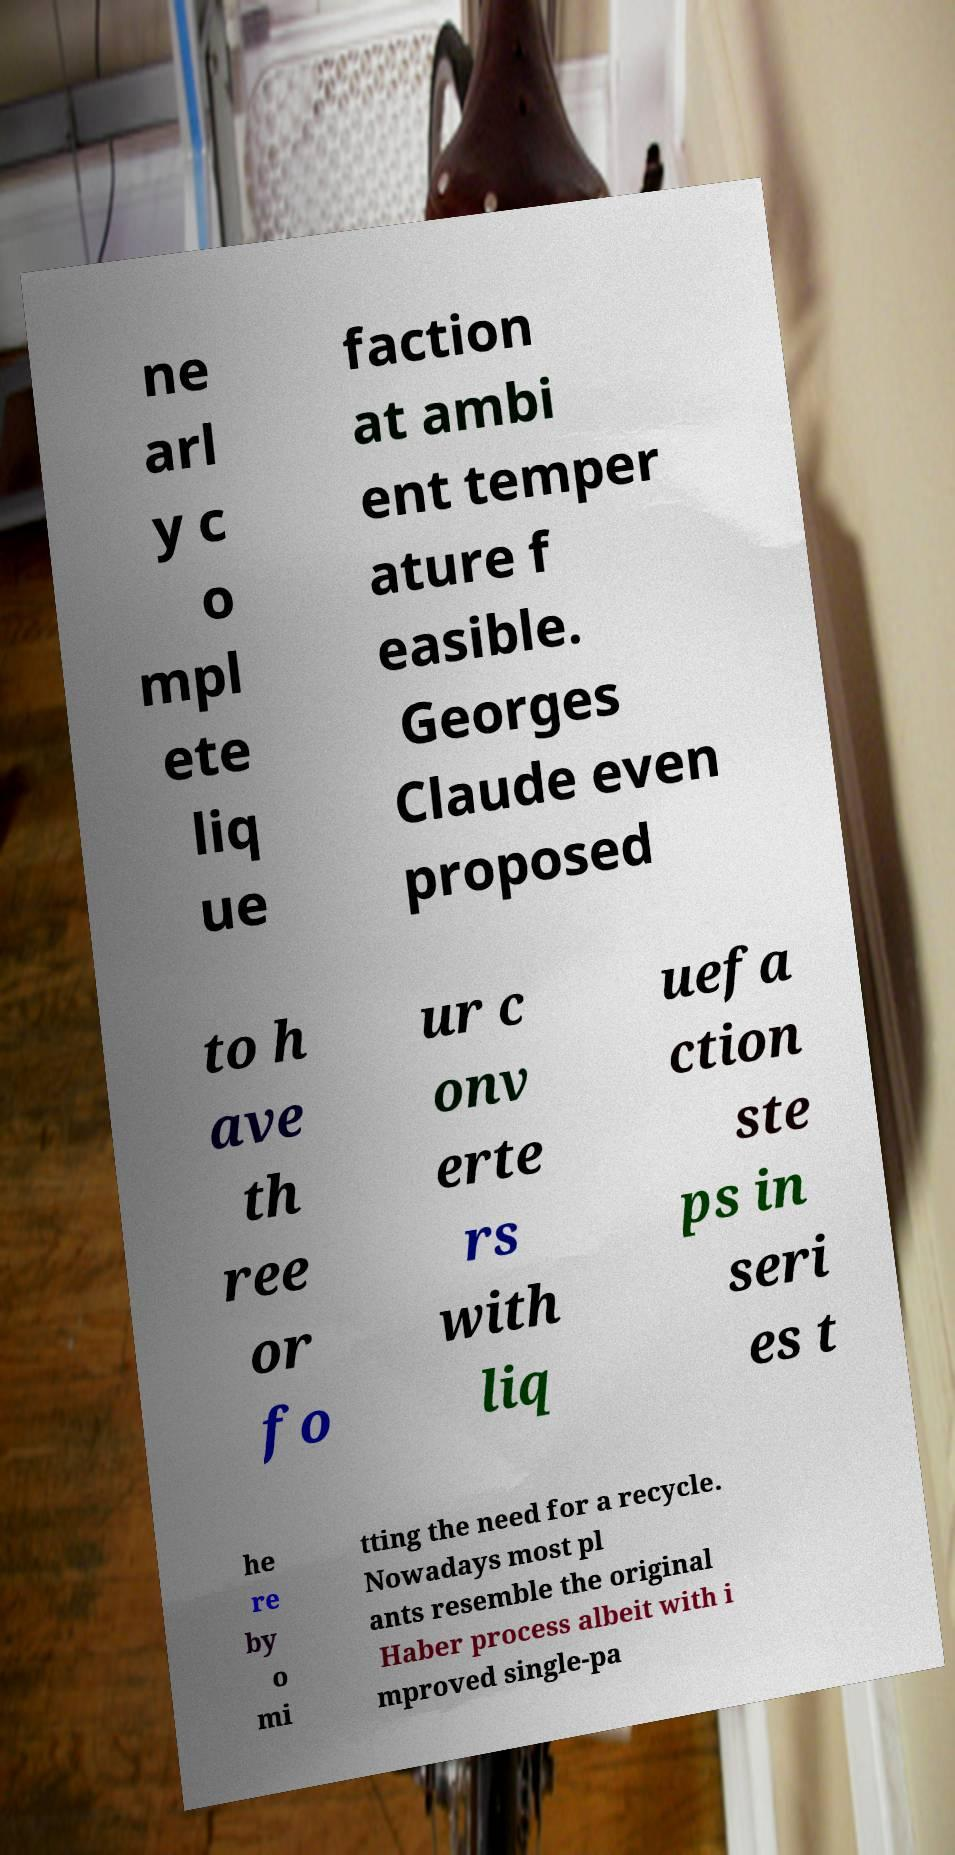Could you assist in decoding the text presented in this image and type it out clearly? ne arl y c o mpl ete liq ue faction at ambi ent temper ature f easible. Georges Claude even proposed to h ave th ree or fo ur c onv erte rs with liq uefa ction ste ps in seri es t he re by o mi tting the need for a recycle. Nowadays most pl ants resemble the original Haber process albeit with i mproved single-pa 